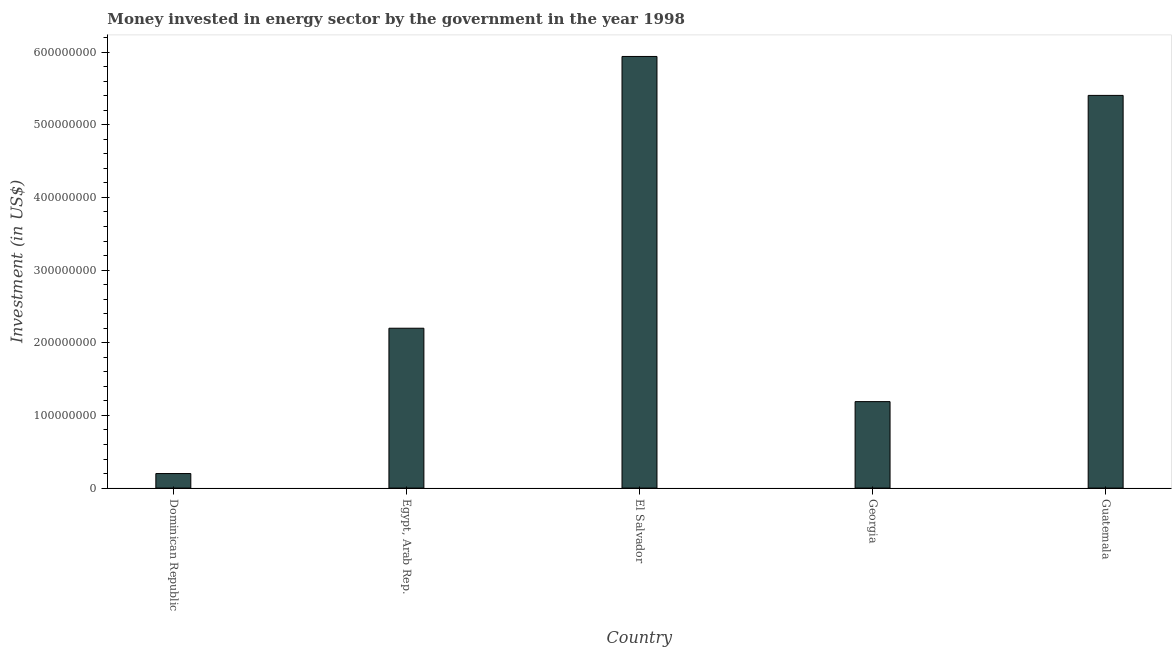Does the graph contain any zero values?
Your response must be concise. No. Does the graph contain grids?
Keep it short and to the point. No. What is the title of the graph?
Provide a short and direct response. Money invested in energy sector by the government in the year 1998. What is the label or title of the X-axis?
Make the answer very short. Country. What is the label or title of the Y-axis?
Make the answer very short. Investment (in US$). What is the investment in energy in Guatemala?
Provide a short and direct response. 5.40e+08. Across all countries, what is the maximum investment in energy?
Provide a succinct answer. 5.94e+08. In which country was the investment in energy maximum?
Offer a terse response. El Salvador. In which country was the investment in energy minimum?
Ensure brevity in your answer.  Dominican Republic. What is the sum of the investment in energy?
Your answer should be very brief. 1.49e+09. What is the difference between the investment in energy in Dominican Republic and Egypt, Arab Rep.?
Ensure brevity in your answer.  -2.00e+08. What is the average investment in energy per country?
Your response must be concise. 2.99e+08. What is the median investment in energy?
Offer a terse response. 2.20e+08. What is the ratio of the investment in energy in El Salvador to that in Guatemala?
Provide a succinct answer. 1.1. What is the difference between the highest and the second highest investment in energy?
Make the answer very short. 5.36e+07. Is the sum of the investment in energy in Egypt, Arab Rep. and Guatemala greater than the maximum investment in energy across all countries?
Ensure brevity in your answer.  Yes. What is the difference between the highest and the lowest investment in energy?
Give a very brief answer. 5.74e+08. How many bars are there?
Ensure brevity in your answer.  5. How many countries are there in the graph?
Make the answer very short. 5. Are the values on the major ticks of Y-axis written in scientific E-notation?
Offer a very short reply. No. What is the Investment (in US$) in Dominican Republic?
Provide a short and direct response. 2.00e+07. What is the Investment (in US$) in Egypt, Arab Rep.?
Provide a short and direct response. 2.20e+08. What is the Investment (in US$) of El Salvador?
Offer a very short reply. 5.94e+08. What is the Investment (in US$) in Georgia?
Your response must be concise. 1.19e+08. What is the Investment (in US$) of Guatemala?
Keep it short and to the point. 5.40e+08. What is the difference between the Investment (in US$) in Dominican Republic and Egypt, Arab Rep.?
Offer a very short reply. -2.00e+08. What is the difference between the Investment (in US$) in Dominican Republic and El Salvador?
Your answer should be compact. -5.74e+08. What is the difference between the Investment (in US$) in Dominican Republic and Georgia?
Ensure brevity in your answer.  -9.90e+07. What is the difference between the Investment (in US$) in Dominican Republic and Guatemala?
Ensure brevity in your answer.  -5.20e+08. What is the difference between the Investment (in US$) in Egypt, Arab Rep. and El Salvador?
Your answer should be very brief. -3.74e+08. What is the difference between the Investment (in US$) in Egypt, Arab Rep. and Georgia?
Your answer should be very brief. 1.01e+08. What is the difference between the Investment (in US$) in Egypt, Arab Rep. and Guatemala?
Offer a terse response. -3.20e+08. What is the difference between the Investment (in US$) in El Salvador and Georgia?
Offer a very short reply. 4.75e+08. What is the difference between the Investment (in US$) in El Salvador and Guatemala?
Provide a short and direct response. 5.36e+07. What is the difference between the Investment (in US$) in Georgia and Guatemala?
Provide a short and direct response. -4.21e+08. What is the ratio of the Investment (in US$) in Dominican Republic to that in Egypt, Arab Rep.?
Provide a short and direct response. 0.09. What is the ratio of the Investment (in US$) in Dominican Republic to that in El Salvador?
Your response must be concise. 0.03. What is the ratio of the Investment (in US$) in Dominican Republic to that in Georgia?
Keep it short and to the point. 0.17. What is the ratio of the Investment (in US$) in Dominican Republic to that in Guatemala?
Offer a terse response. 0.04. What is the ratio of the Investment (in US$) in Egypt, Arab Rep. to that in El Salvador?
Keep it short and to the point. 0.37. What is the ratio of the Investment (in US$) in Egypt, Arab Rep. to that in Georgia?
Ensure brevity in your answer.  1.85. What is the ratio of the Investment (in US$) in Egypt, Arab Rep. to that in Guatemala?
Provide a succinct answer. 0.41. What is the ratio of the Investment (in US$) in El Salvador to that in Georgia?
Keep it short and to the point. 4.99. What is the ratio of the Investment (in US$) in El Salvador to that in Guatemala?
Ensure brevity in your answer.  1.1. What is the ratio of the Investment (in US$) in Georgia to that in Guatemala?
Offer a terse response. 0.22. 